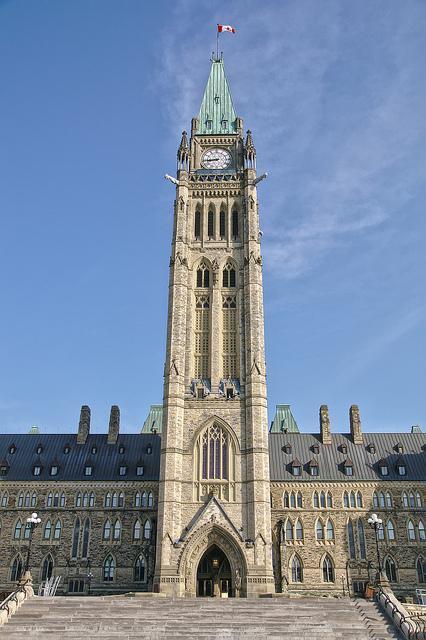How many buildings do you see?
Give a very brief answer. 1. 